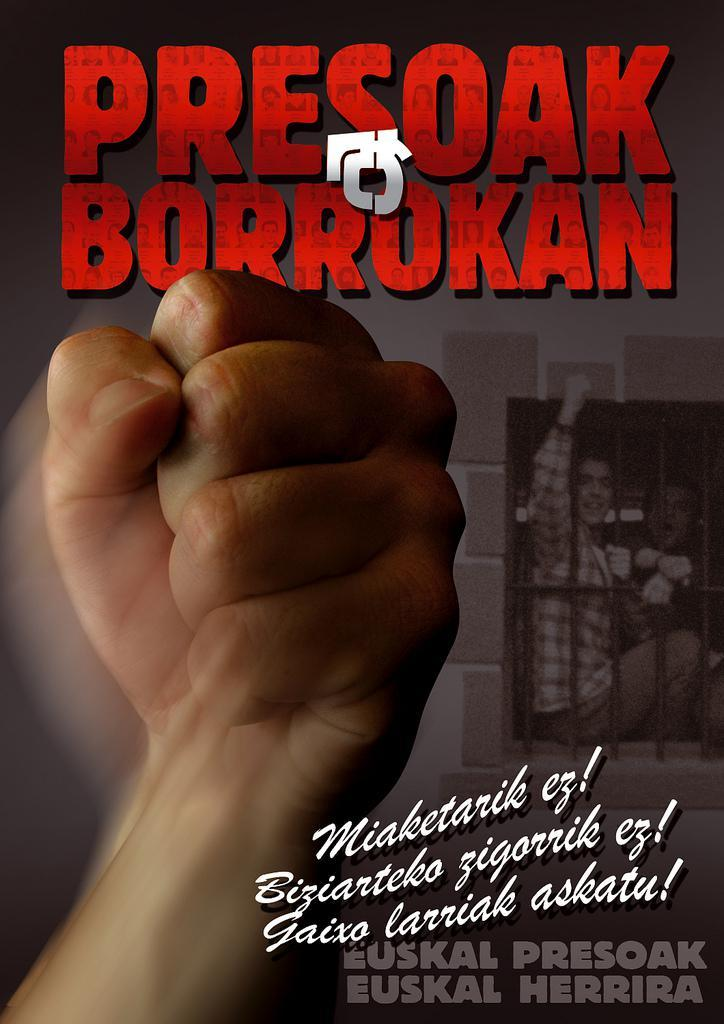What part of a person can be seen in the image? There is a person's hand in the image. What is featured on the poster in the image? The poster contains images of people and a window. Is there any text on the poster in the image? Yes, there is text written on the poster. What type of acoustics can be heard from the poster in the image? There is no sound or acoustics present in the image, as it is a static representation of a poster. Can you describe the argument taking place between the people depicted on the poster? There is no argument depicted on the poster; it features images of people and a window with text. 